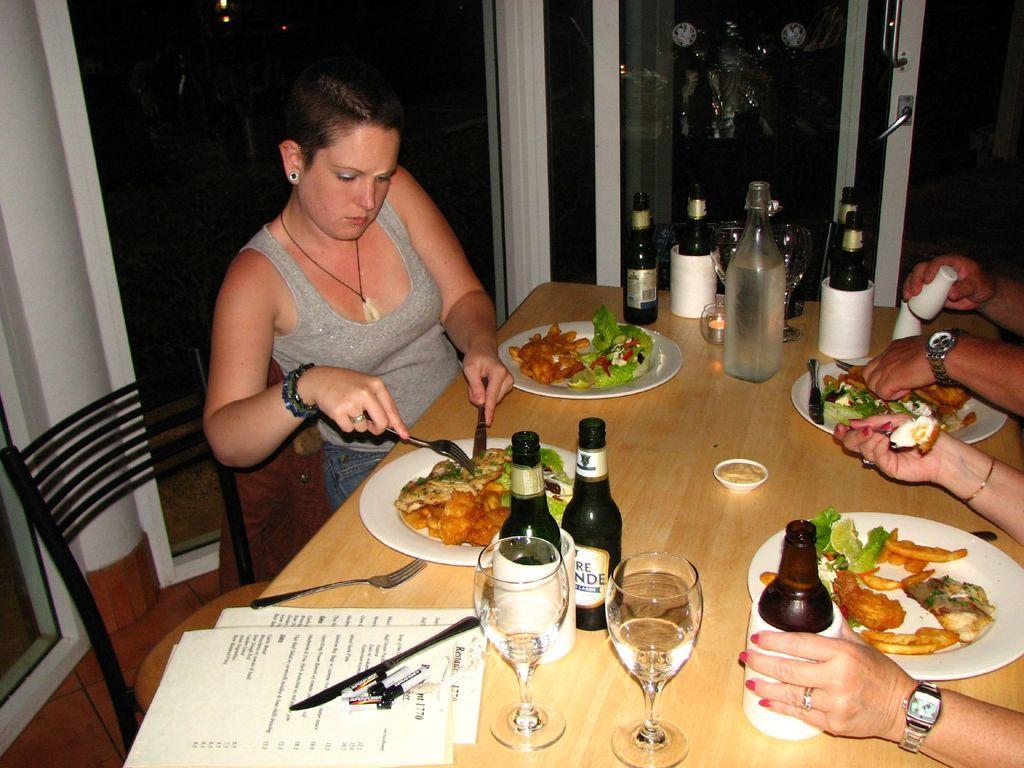In one or two sentences, can you explain what this image depicts? Here in this picture we can see a woman sitting on a chair with table in front of her with papers and plates of food, bottles and glasses all present on it over there and in front her also we can see other people sitting and beside her we can see a door present over there. 